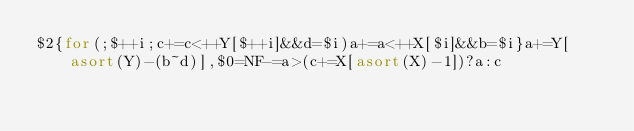<code> <loc_0><loc_0><loc_500><loc_500><_Awk_>$2{for(;$++i;c+=c<++Y[$++i]&&d=$i)a+=a<++X[$i]&&b=$i}a+=Y[asort(Y)-(b~d)],$0=NF-=a>(c+=X[asort(X)-1])?a:c</code> 